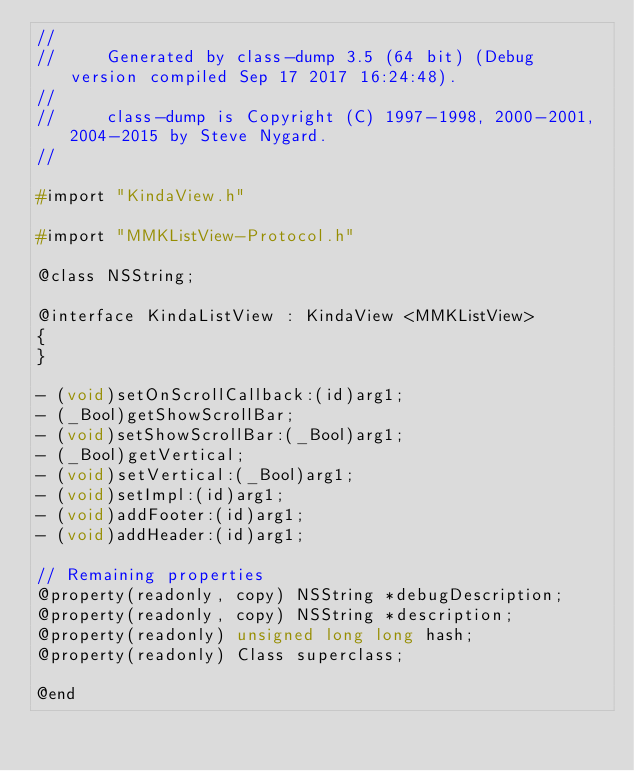Convert code to text. <code><loc_0><loc_0><loc_500><loc_500><_C_>//
//     Generated by class-dump 3.5 (64 bit) (Debug version compiled Sep 17 2017 16:24:48).
//
//     class-dump is Copyright (C) 1997-1998, 2000-2001, 2004-2015 by Steve Nygard.
//

#import "KindaView.h"

#import "MMKListView-Protocol.h"

@class NSString;

@interface KindaListView : KindaView <MMKListView>
{
}

- (void)setOnScrollCallback:(id)arg1;
- (_Bool)getShowScrollBar;
- (void)setShowScrollBar:(_Bool)arg1;
- (_Bool)getVertical;
- (void)setVertical:(_Bool)arg1;
- (void)setImpl:(id)arg1;
- (void)addFooter:(id)arg1;
- (void)addHeader:(id)arg1;

// Remaining properties
@property(readonly, copy) NSString *debugDescription;
@property(readonly, copy) NSString *description;
@property(readonly) unsigned long long hash;
@property(readonly) Class superclass;

@end

</code> 